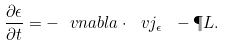Convert formula to latex. <formula><loc_0><loc_0><loc_500><loc_500>\frac { \partial \epsilon } { \partial t } = - \ v n a b l a \cdot \ v j _ { \epsilon } \ - \P L .</formula> 